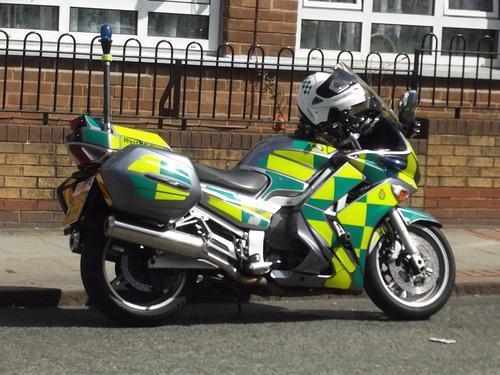How many motorcycles are in this picture?
Give a very brief answer. 1. How many wheels are on the motorcycle?
Give a very brief answer. 2. 